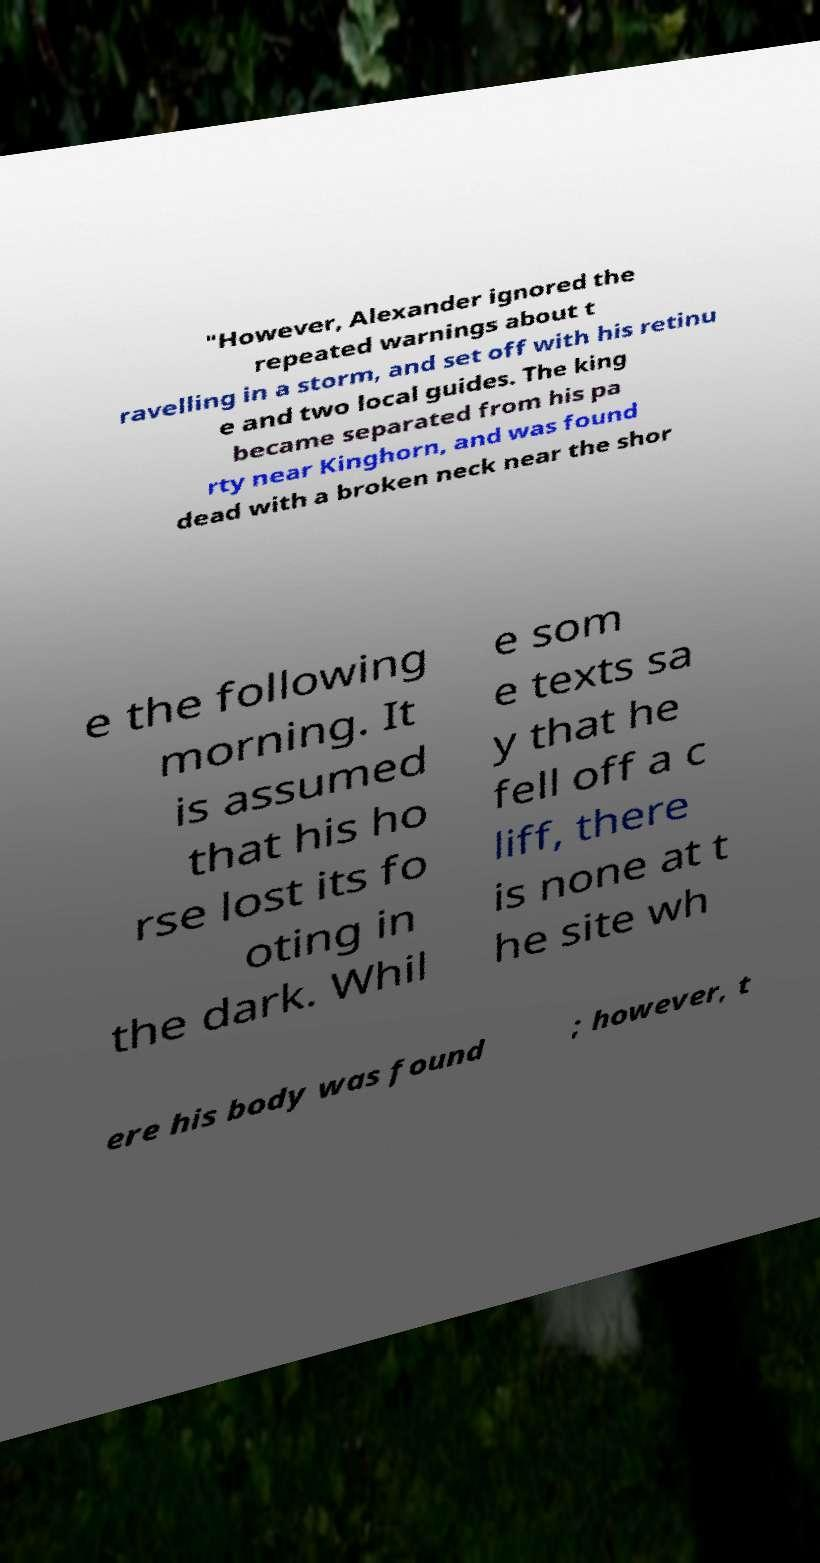I need the written content from this picture converted into text. Can you do that? "However, Alexander ignored the repeated warnings about t ravelling in a storm, and set off with his retinu e and two local guides. The king became separated from his pa rty near Kinghorn, and was found dead with a broken neck near the shor e the following morning. It is assumed that his ho rse lost its fo oting in the dark. Whil e som e texts sa y that he fell off a c liff, there is none at t he site wh ere his body was found ; however, t 